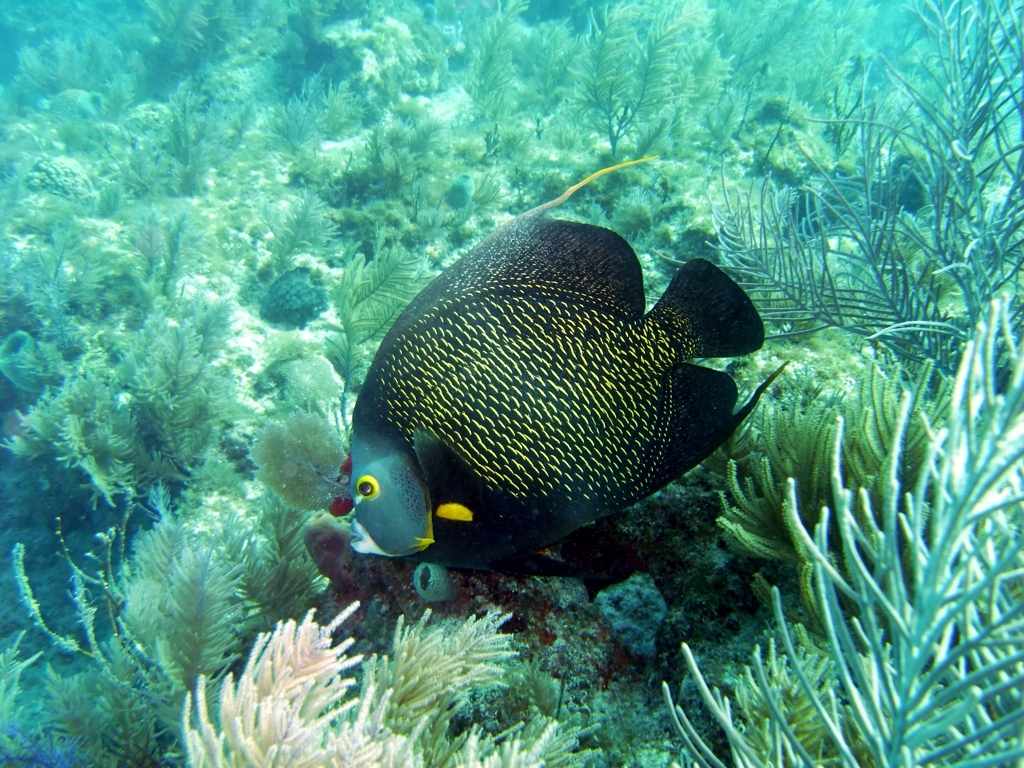Is the underwater environment clear and visible?
A. No
B. Yes
Answer with the option's letter from the given choices directly.
 B. 